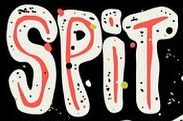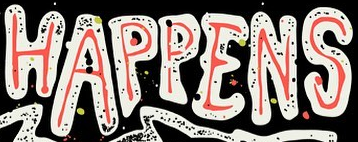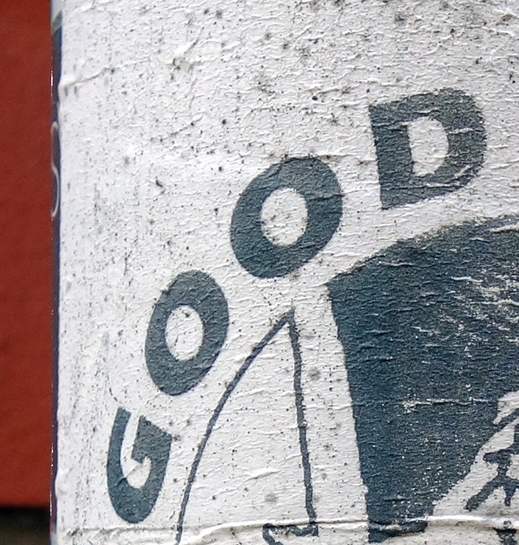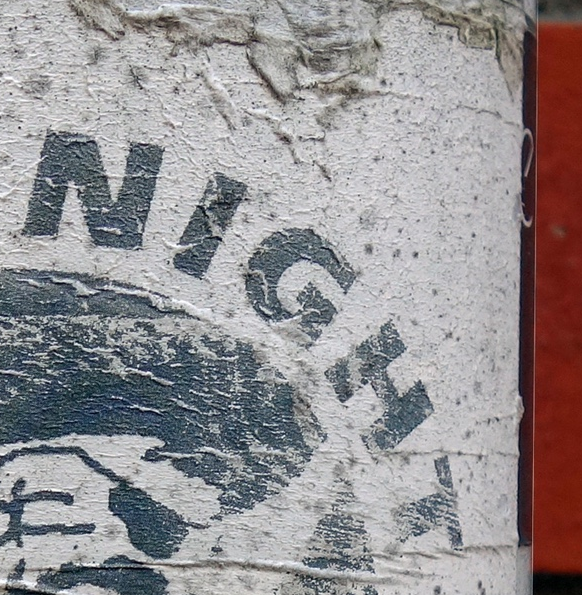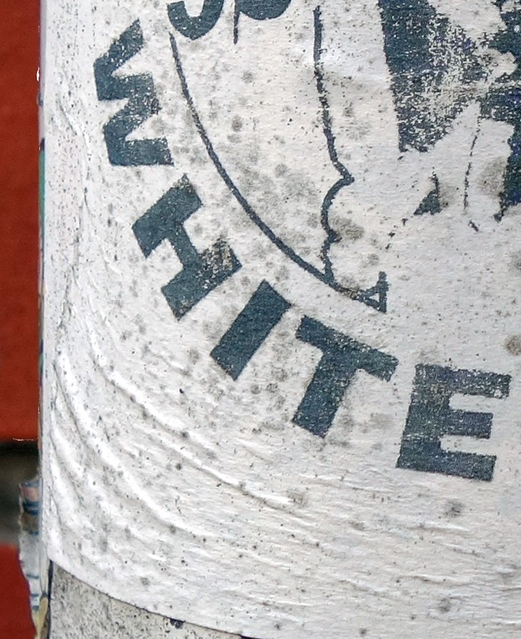Read the text content from these images in order, separated by a semicolon. SPiT; HAPPENS; GOOD; NIGHT; WHITE 